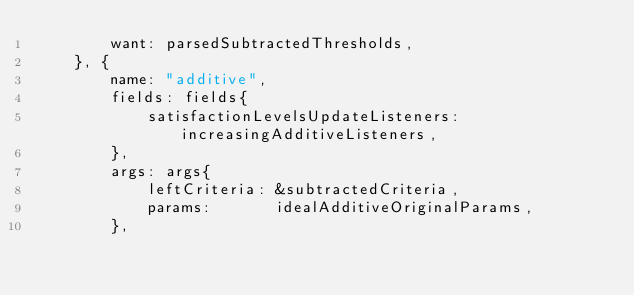Convert code to text. <code><loc_0><loc_0><loc_500><loc_500><_Go_>		want: parsedSubtractedThresholds,
	}, {
		name: "additive",
		fields: fields{
			satisfactionLevelsUpdateListeners: increasingAdditiveListeners,
		},
		args: args{
			leftCriteria: &subtractedCriteria,
			params:       idealAdditiveOriginalParams,
		},</code> 